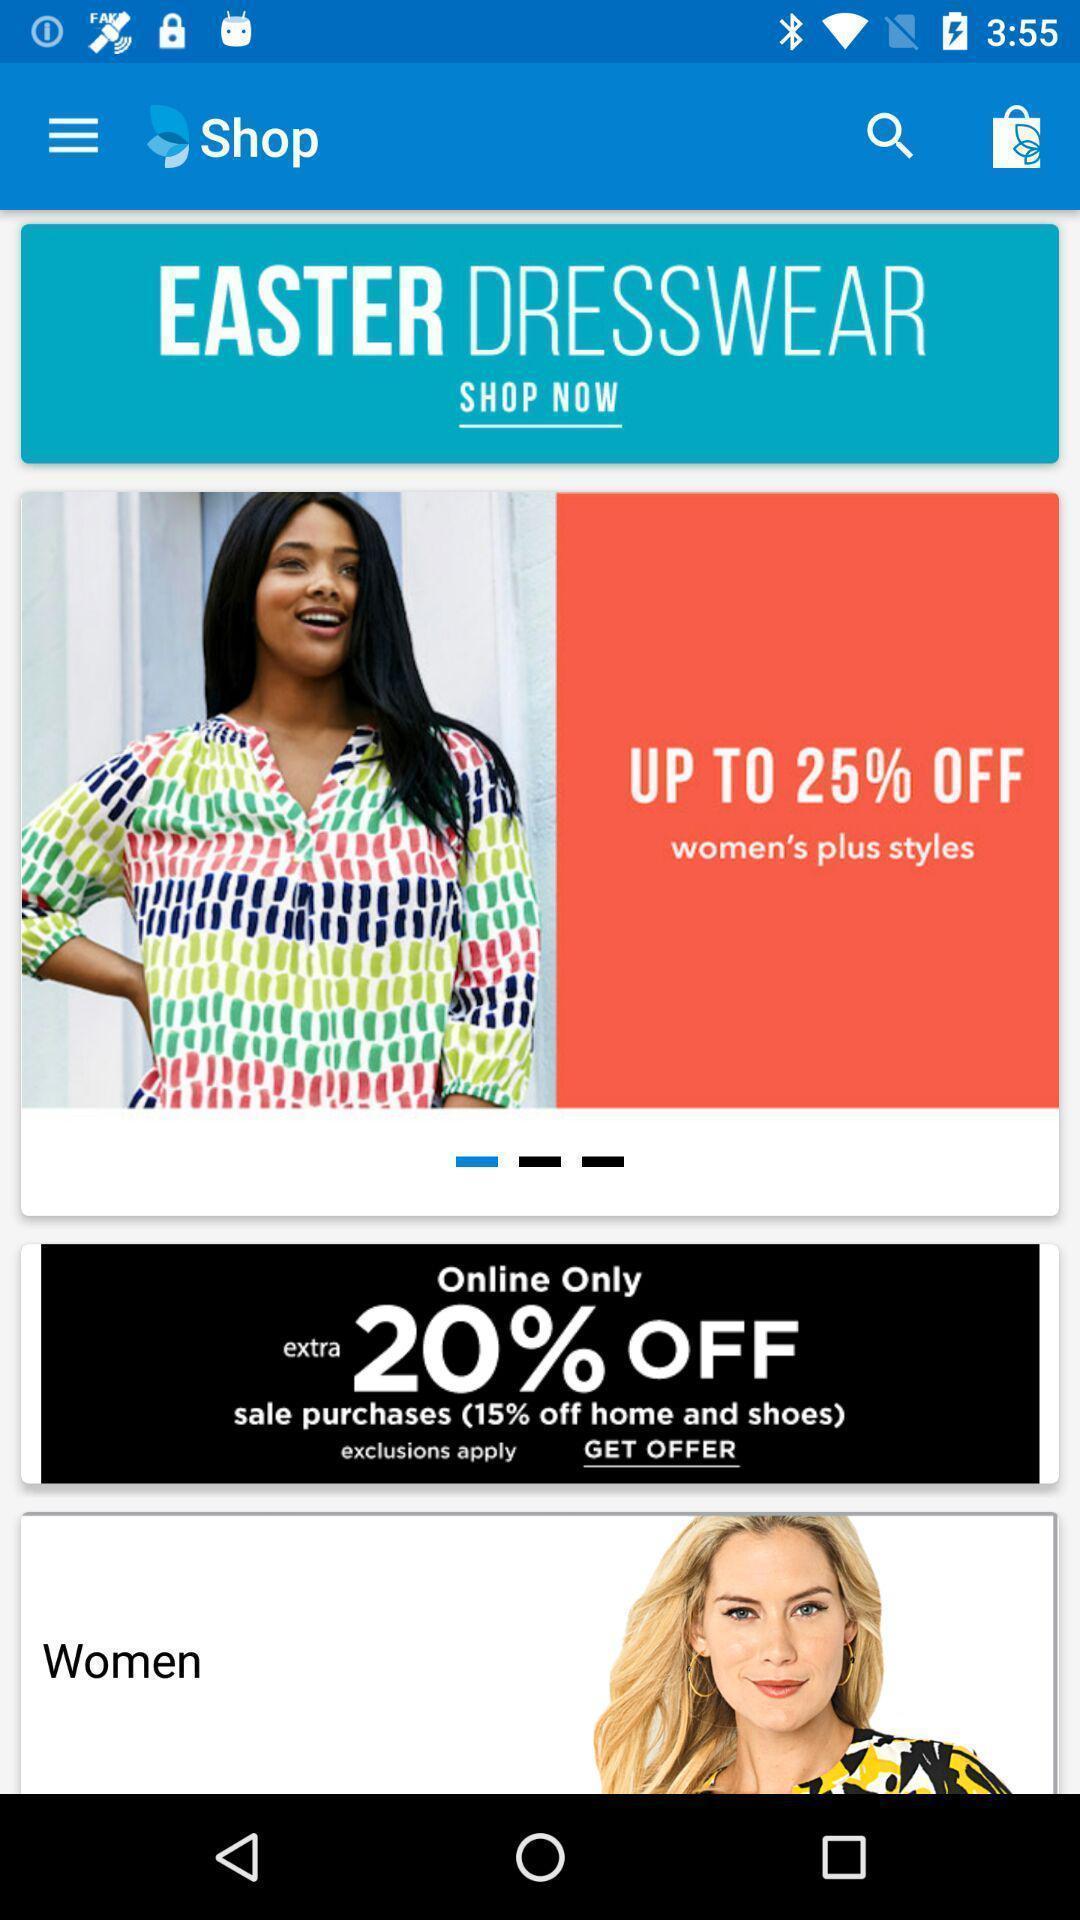Describe the content in this image. Page that displaying shopping application. 